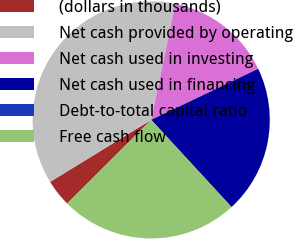<chart> <loc_0><loc_0><loc_500><loc_500><pie_chart><fcel>(dollars in thousands)<fcel>Net cash provided by operating<fcel>Net cash used in investing<fcel>Net cash used in financing<fcel>Debt-to-total capital ratio<fcel>Free cash flow<nl><fcel>3.7%<fcel>37.03%<fcel>14.64%<fcel>20.23%<fcel>0.0%<fcel>24.39%<nl></chart> 